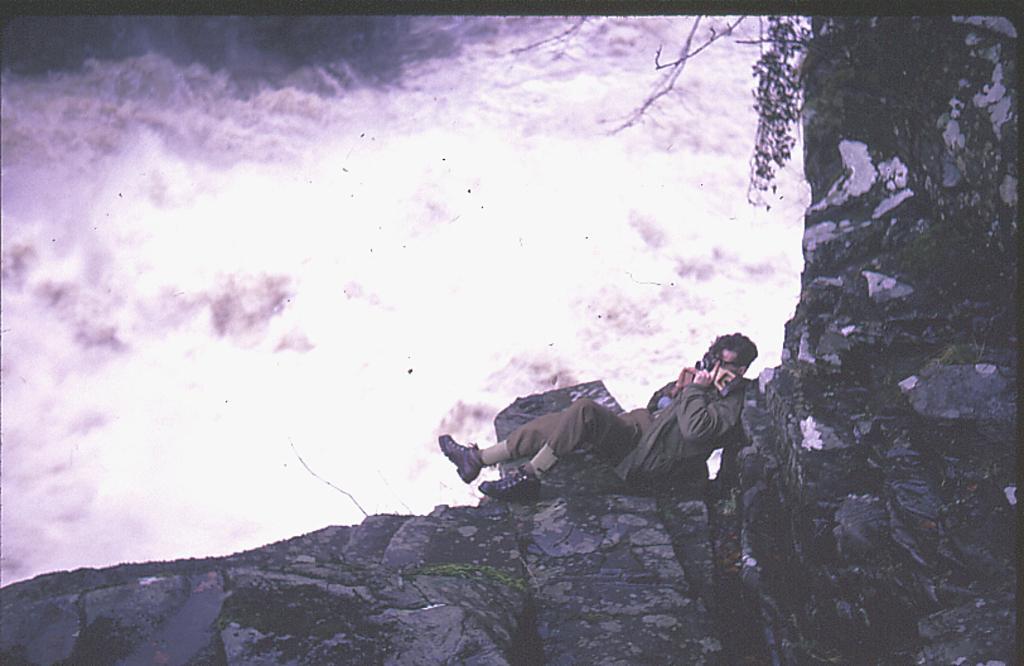Could you give a brief overview of what you see in this image? The picture looks like an edited image. In the foreground and towards right we can see rocks, plant and a person. At the top and towards left there are clouds. 